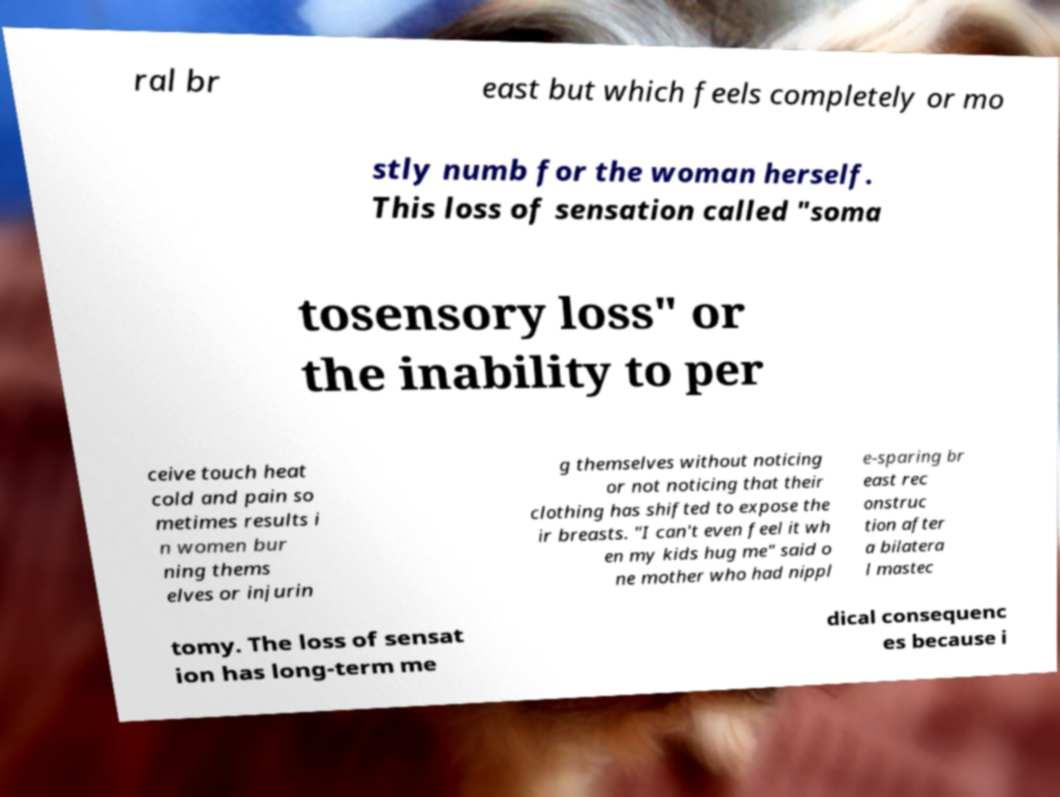Can you accurately transcribe the text from the provided image for me? ral br east but which feels completely or mo stly numb for the woman herself. This loss of sensation called "soma tosensory loss" or the inability to per ceive touch heat cold and pain so metimes results i n women bur ning thems elves or injurin g themselves without noticing or not noticing that their clothing has shifted to expose the ir breasts. "I can't even feel it wh en my kids hug me" said o ne mother who had nippl e-sparing br east rec onstruc tion after a bilatera l mastec tomy. The loss of sensat ion has long-term me dical consequenc es because i 